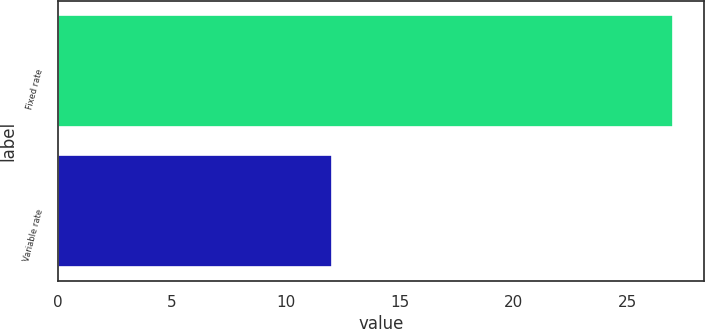Convert chart. <chart><loc_0><loc_0><loc_500><loc_500><bar_chart><fcel>Fixed rate<fcel>Variable rate<nl><fcel>27<fcel>12<nl></chart> 